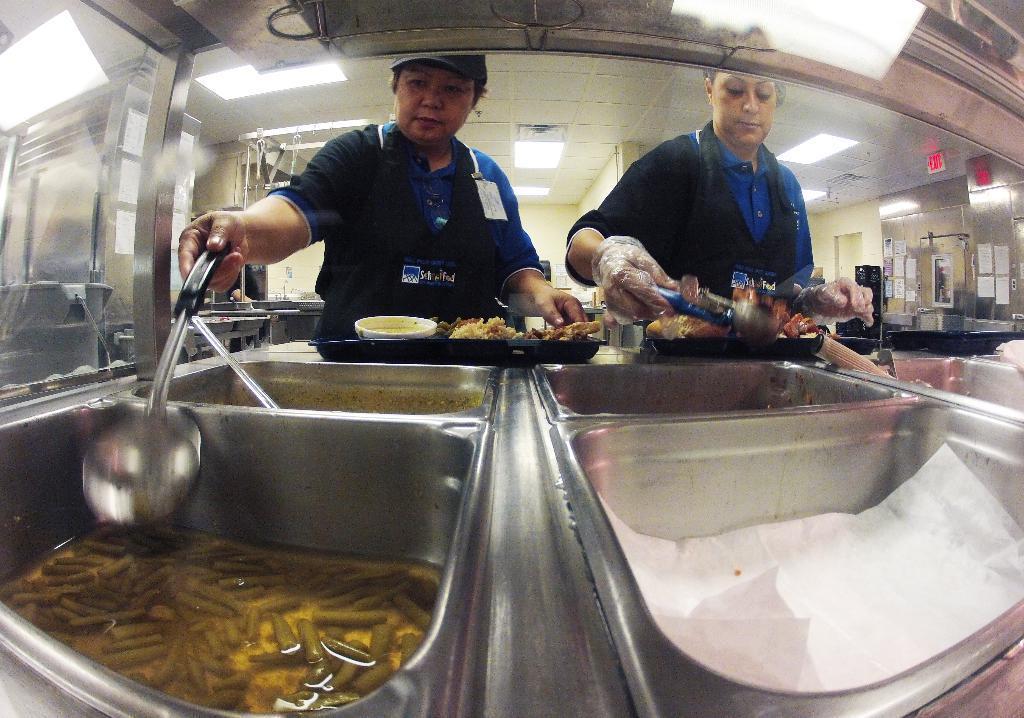In one or two sentences, can you explain what this image depicts? In this image there is a glass in which we can see metal objects on the left corner. There are posters on the wall in the right corner. There is a food in the steel vessels, there are people, there is food on the plate. There are lights on the roof at the top. 